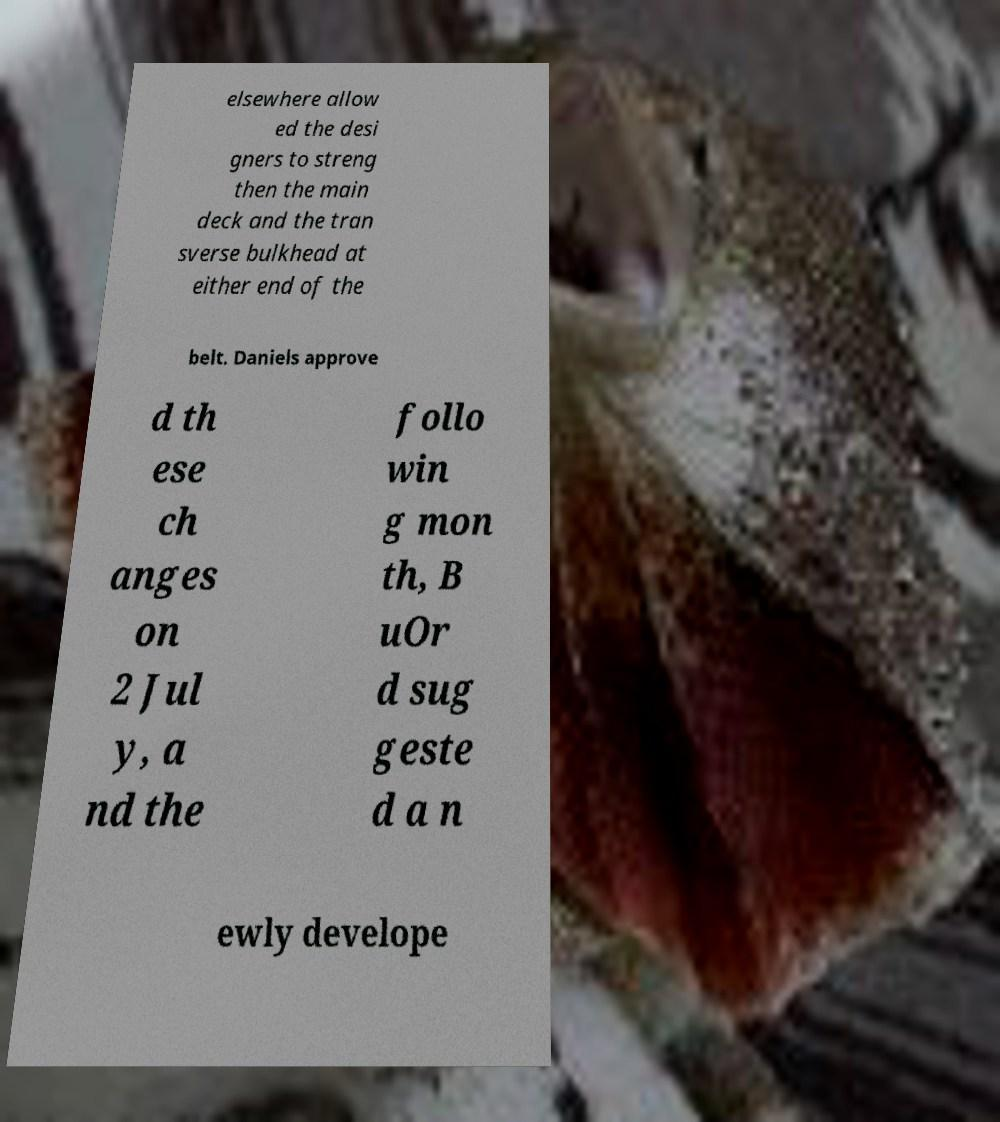I need the written content from this picture converted into text. Can you do that? elsewhere allow ed the desi gners to streng then the main deck and the tran sverse bulkhead at either end of the belt. Daniels approve d th ese ch anges on 2 Jul y, a nd the follo win g mon th, B uOr d sug geste d a n ewly develope 